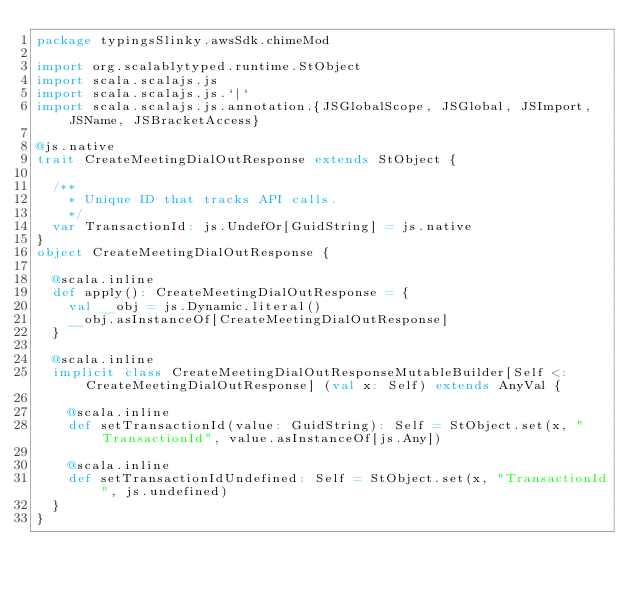<code> <loc_0><loc_0><loc_500><loc_500><_Scala_>package typingsSlinky.awsSdk.chimeMod

import org.scalablytyped.runtime.StObject
import scala.scalajs.js
import scala.scalajs.js.`|`
import scala.scalajs.js.annotation.{JSGlobalScope, JSGlobal, JSImport, JSName, JSBracketAccess}

@js.native
trait CreateMeetingDialOutResponse extends StObject {
  
  /**
    * Unique ID that tracks API calls.
    */
  var TransactionId: js.UndefOr[GuidString] = js.native
}
object CreateMeetingDialOutResponse {
  
  @scala.inline
  def apply(): CreateMeetingDialOutResponse = {
    val __obj = js.Dynamic.literal()
    __obj.asInstanceOf[CreateMeetingDialOutResponse]
  }
  
  @scala.inline
  implicit class CreateMeetingDialOutResponseMutableBuilder[Self <: CreateMeetingDialOutResponse] (val x: Self) extends AnyVal {
    
    @scala.inline
    def setTransactionId(value: GuidString): Self = StObject.set(x, "TransactionId", value.asInstanceOf[js.Any])
    
    @scala.inline
    def setTransactionIdUndefined: Self = StObject.set(x, "TransactionId", js.undefined)
  }
}
</code> 